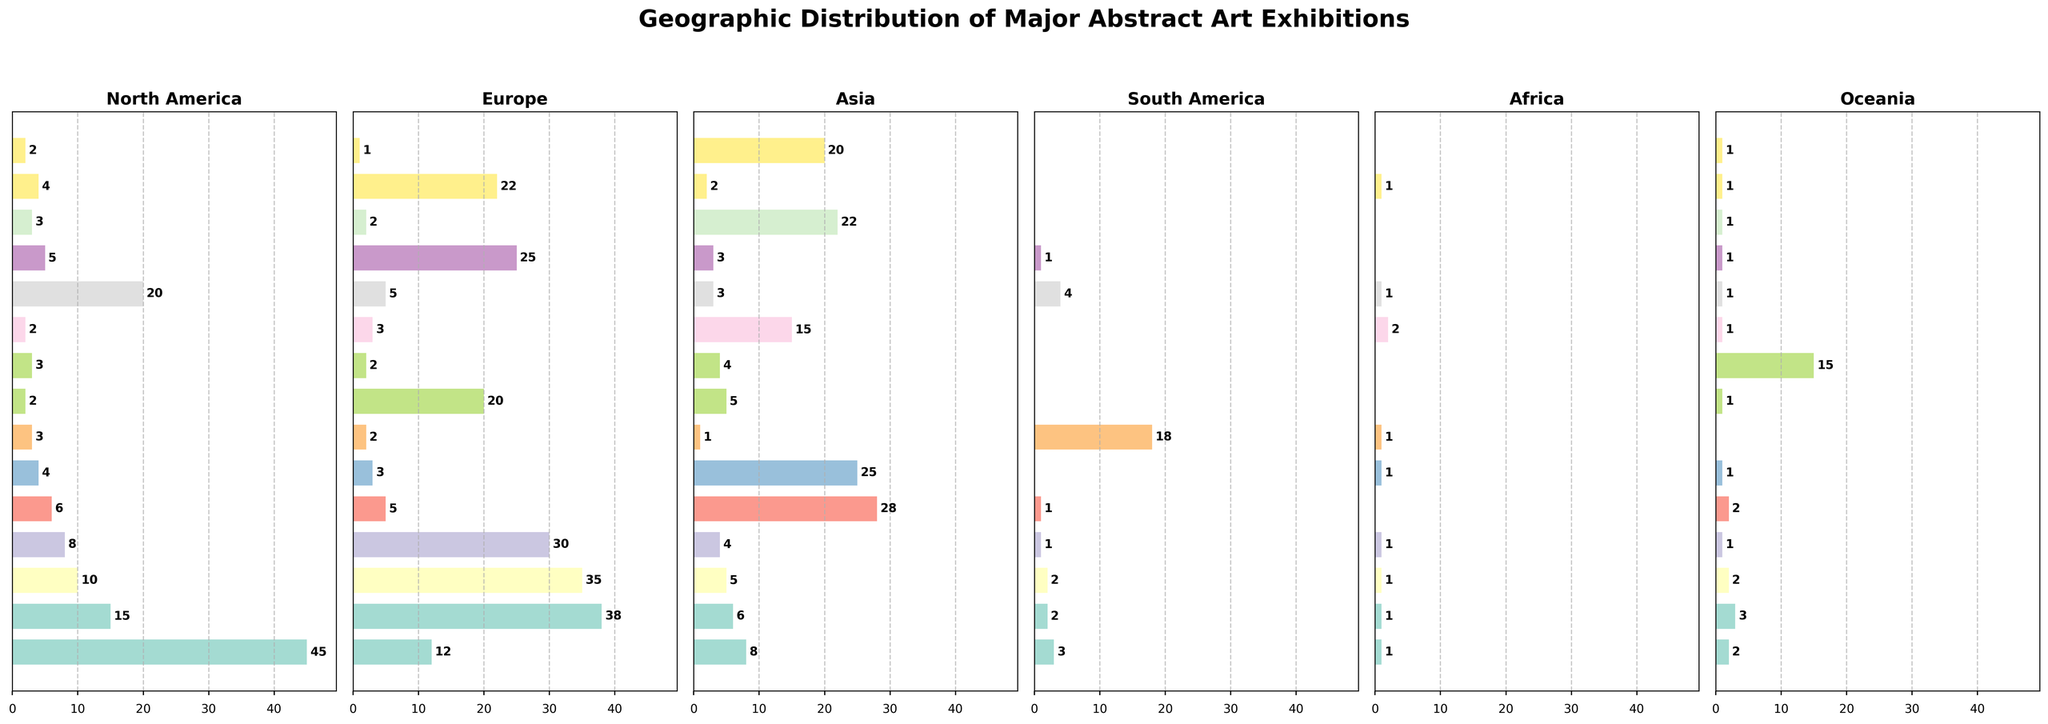Which city has the highest number of exhibitions in North America? Looking at the horizontal bar chart under the "North America" column, we see that New York has the longest bar, indicating the highest number of exhibitions.
Answer: New York Which city has the fewest exhibitions in Europe? Examining the bar lengths in the "Europe" column, we find that São Paulo has the shortest bar.
Answer: São Paulo What is the total number of exhibitions held in Tokyo across all regions? Adding the values for Tokyo in each region gives: 6 (North America) + 5 (Europe) + 28 (Asia) + 1 (South America) + 0 (Africa) + 2 (Oceania) = 42
Answer: 42 How many more exhibitions does Beijing have in Asia compared to London? Beijing has 25 exhibitions in Asia, and London has 6. Subtracting these gives: 25 - 6 = 19
Answer: 19 Which region hosts the most exhibitions in Sydney? Looking at the bars for Sydney, the longest bar is under the "Oceania" column.
Answer: Oceania Does New York have more exhibitions in North America or Europe? Comparing the bar lengths in North America (45) and Europe (12) for New York, North America has a longer bar.
Answer: North America Which two cities have the same number of exhibitions in South America? Both New York and Miami each have 4 exhibitions in South America, as indicated by the bars.
Answer: New York and Miami What is the average number of exhibitions in Tokyo in North America and Europe? Adding the values for Tokyo in North America (6) and Europe (5), then dividing by 2: (6 + 5) / 2 = 5.5
Answer: 5.5 How many total exhibitions are there in Africa? Summing the values in the Africa column: 1 + 1 + 1 + 1 + 0 + 1 + 1 + 0 + 0 + 2 + 1 + 0 + 0 + 1 + 0 = 9
Answer: 9 